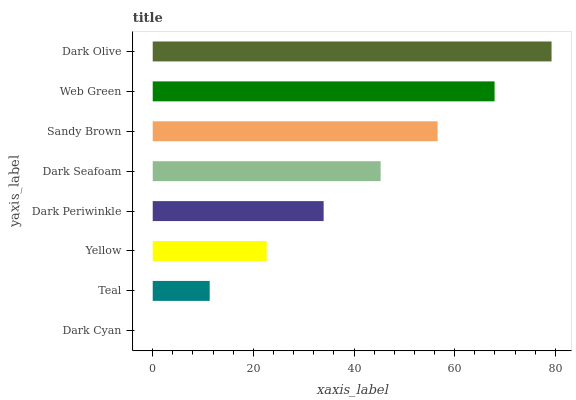Is Dark Cyan the minimum?
Answer yes or no. Yes. Is Dark Olive the maximum?
Answer yes or no. Yes. Is Teal the minimum?
Answer yes or no. No. Is Teal the maximum?
Answer yes or no. No. Is Teal greater than Dark Cyan?
Answer yes or no. Yes. Is Dark Cyan less than Teal?
Answer yes or no. Yes. Is Dark Cyan greater than Teal?
Answer yes or no. No. Is Teal less than Dark Cyan?
Answer yes or no. No. Is Dark Seafoam the high median?
Answer yes or no. Yes. Is Dark Periwinkle the low median?
Answer yes or no. Yes. Is Dark Periwinkle the high median?
Answer yes or no. No. Is Dark Cyan the low median?
Answer yes or no. No. 